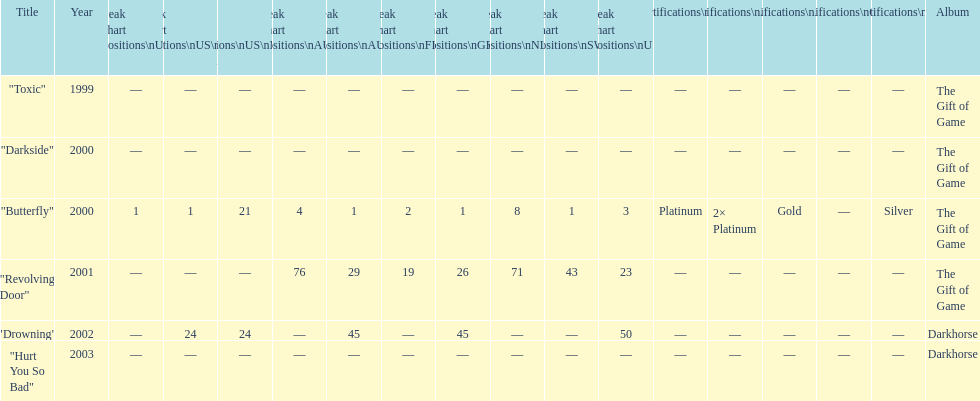How many singles have a ranking of 1 under ger? 1. 